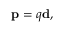<formula> <loc_0><loc_0><loc_500><loc_500>p = q d ,</formula> 